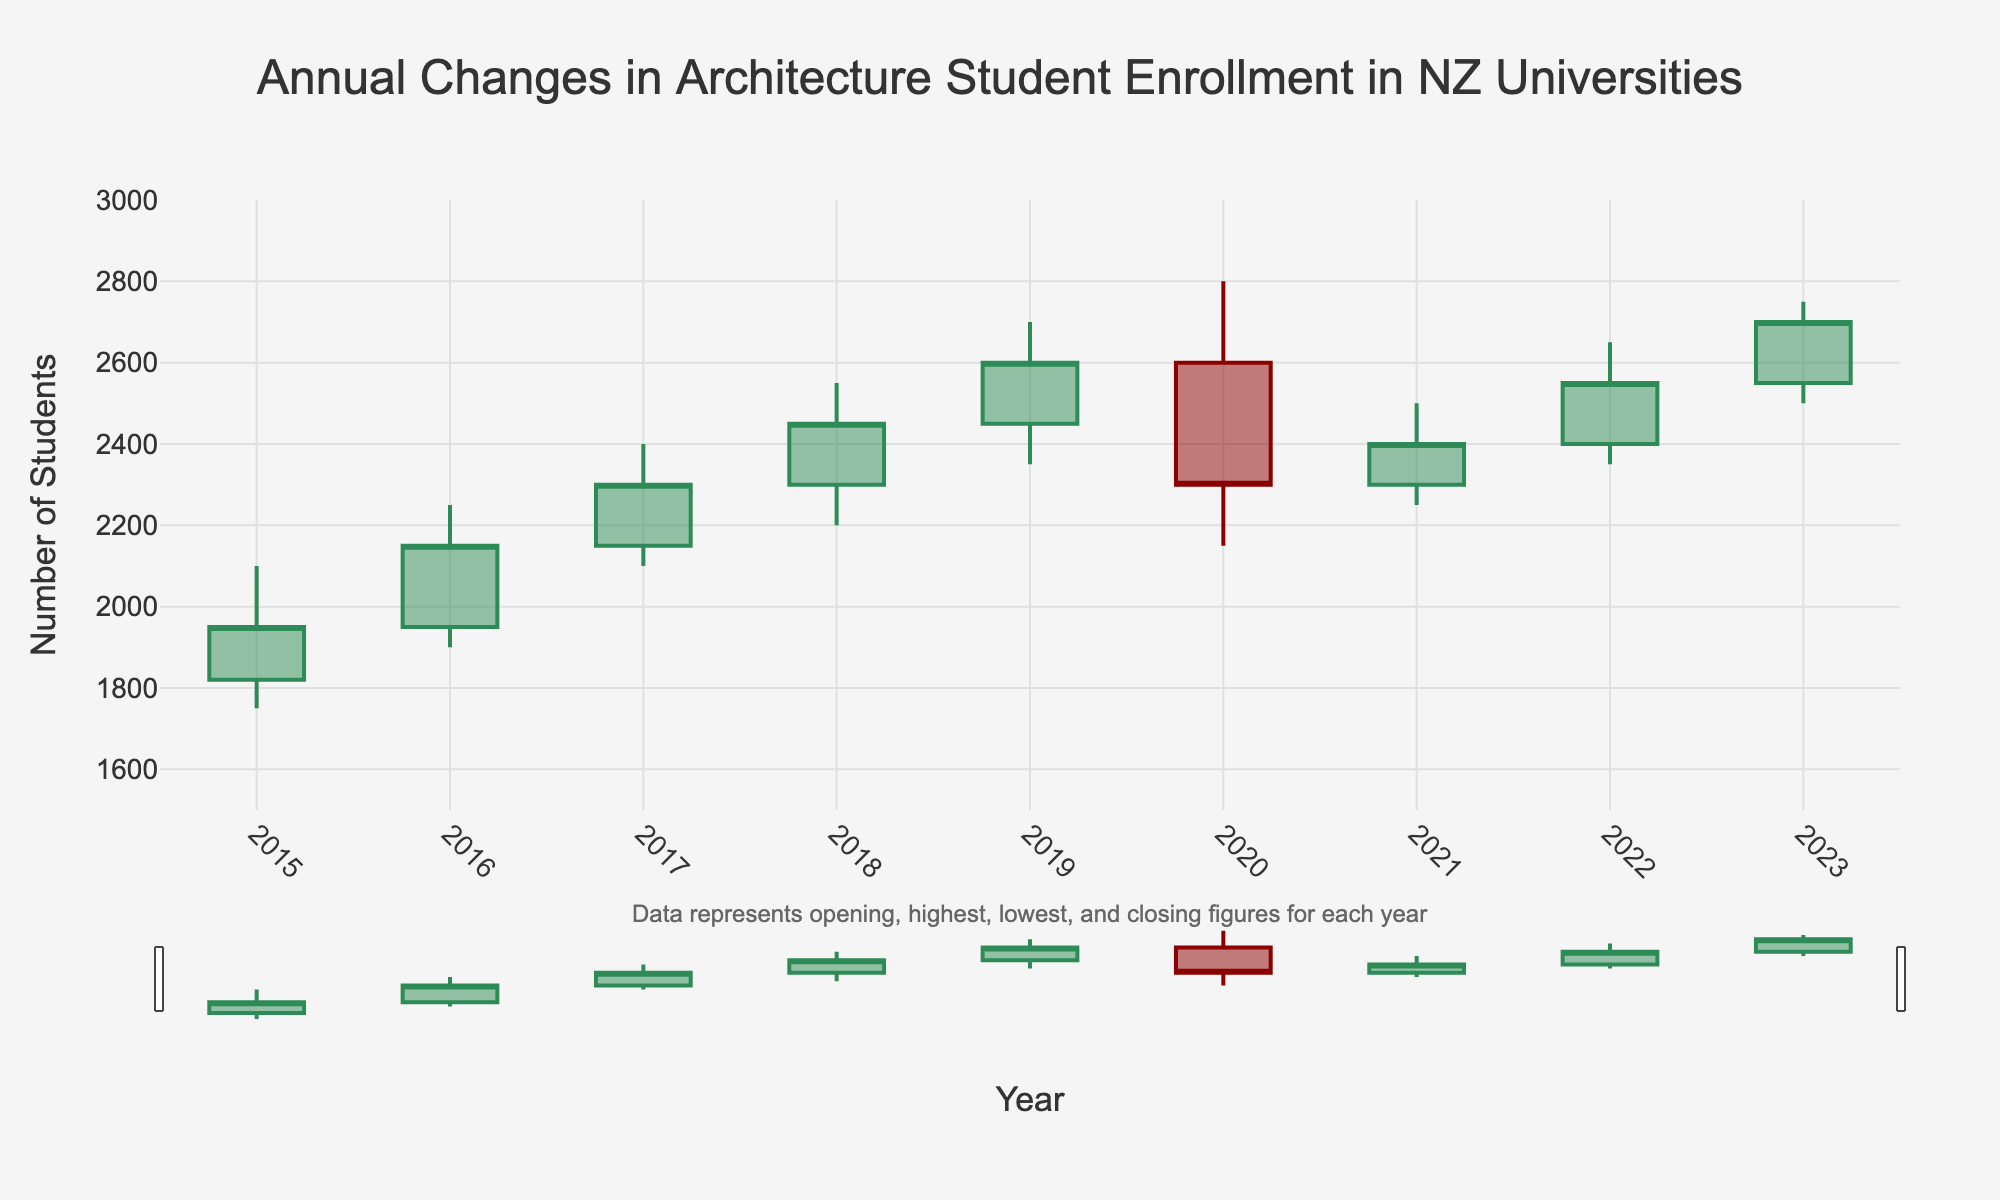What is the title of the figure? The title is located at the top-center of the figure. It reads: 'Annual Changes in Architecture Student Enrollment in NZ Universities'.
Answer: Annual Changes in Architecture Student Enrollment in NZ Universities In which year was the highest enrollment figure recorded? To find the highest enrollment figure, look at the highest values (peaks) for each year. The highest peak is in 2020, marking 2800 students.
Answer: 2020 What is the color of the lines representing increasing figures? The lines representing increasing figures are colored green, as indicated in the legend.
Answer: Green Which year had the lowest closing enrollment figure? Find the lowest points among the closing figures. The lowest closing figure is in 2020, with 2300 students.
Answer: 2020 How does the enrollment trend from 2015 to 2016 compare to the trend from 2018 to 2019? Compare the opening, highest, lowest, and closing figures for these years. Both periods show an increasing trend, but the increase from 2018 to 2019 is more pronounced. 2015 to 2016: 1820 to 2150; 2018 to 2019: 2300 to 2600.
Answer: 2015 to 2016 shows an increase, but 2018 to 2019 has a more significant increase What are the highest and lowest enrollment figures for 2021? For 2021, the highest enrollment figure is 2500, and the lowest is 2250.
Answer: 2500 (highest) and 2250 (lowest) During which year did the enrollment close lower than it opened? Compare the opening and closing figures for each year. In 2020, the enrollment closed at 2300, which is lower than its opening figure of 2600.
Answer: 2020 What was the maximum decline in the lowest enrollment figure from one year to another? Calculate the difference in the lowest enrollment figure between successive years. The maximum decline is from 2020 to 2021, dropping from 2150 to 2250.
Answer: 100 students (2150 to 2250, from 2020 to 2021) How many years saw an increase in the closing enrollment figure compared to the opening figure? Count the years when the closing figure was higher than the opening figure. This happened in 2015 (1950), 2016 (2150), 2017 (2300), 2018 (2450), 2019 (2600), 2021 (2400), 2022 (2550), and 2023 (2700). In total, 8 years saw an increase.
Answer: 8 years 